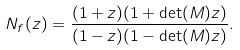<formula> <loc_0><loc_0><loc_500><loc_500>N _ { f } ( z ) = \frac { ( 1 + z ) ( 1 + \det ( M ) z ) } { ( 1 - z ) ( 1 - \det ( M ) z ) } .</formula> 